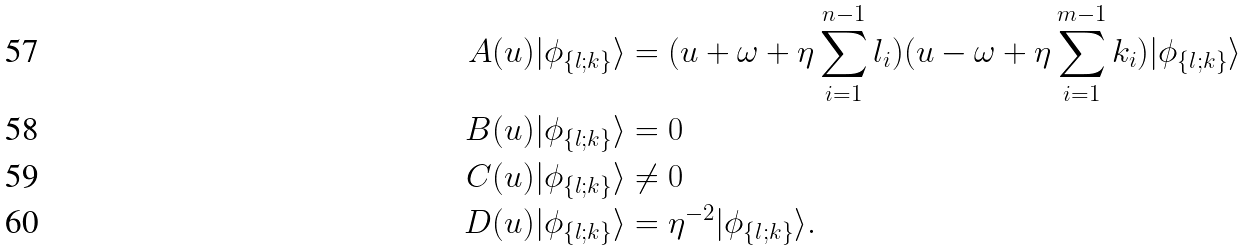<formula> <loc_0><loc_0><loc_500><loc_500>A ( u ) | \phi _ { \{ l ; k \} } \rangle & = ( u + \omega + \eta \sum _ { i = 1 } ^ { n - 1 } l _ { i } ) ( u - \omega + \eta \sum _ { i = 1 } ^ { m - 1 } k _ { i } ) | \phi _ { \{ l ; k \} } \rangle \\ B ( u ) | \phi _ { \{ l ; k \} } \rangle & = 0 \\ C ( u ) | \phi _ { \{ l ; k \} } \rangle & \neq 0 \\ D ( u ) | \phi _ { \{ l ; k \} } \rangle & = \eta ^ { - 2 } | \phi _ { \{ l ; k \} } \rangle .</formula> 